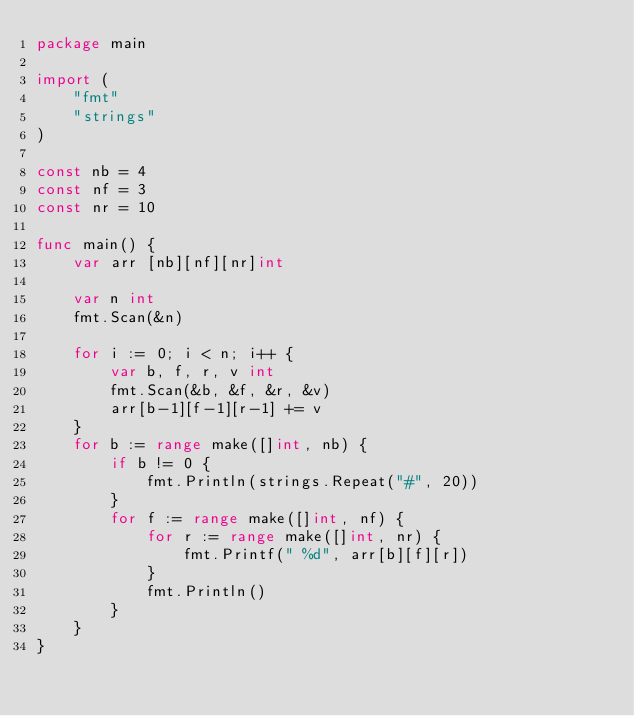Convert code to text. <code><loc_0><loc_0><loc_500><loc_500><_Go_>package main

import (
	"fmt"
	"strings"
)

const nb = 4
const nf = 3
const nr = 10

func main() {
	var arr [nb][nf][nr]int

	var n int
	fmt.Scan(&n)

	for i := 0; i < n; i++ {
		var b, f, r, v int
		fmt.Scan(&b, &f, &r, &v)
		arr[b-1][f-1][r-1] += v
	}
	for b := range make([]int, nb) {
		if b != 0 {
			fmt.Println(strings.Repeat("#", 20))
		}
		for f := range make([]int, nf) {
			for r := range make([]int, nr) {
				fmt.Printf(" %d", arr[b][f][r])
			}
			fmt.Println()
		}
	}
}

</code> 